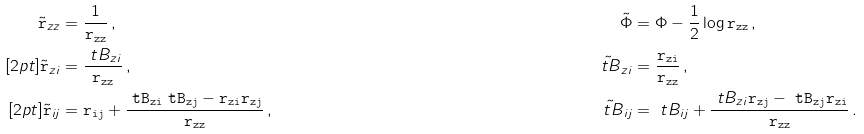Convert formula to latex. <formula><loc_0><loc_0><loc_500><loc_500>\tilde { \tt r } _ { z z } & = \frac { 1 } { \tt r _ { z z } } \, , & \tilde { \Phi } & = \Phi - \frac { 1 } { 2 } \log \tt r _ { z z } \, , \\ [ 2 p t ] \tilde { \tt r } _ { z i } & = \frac { \ t B _ { z i } } { \tt r _ { z z } } \, , & \tilde { \ t B } _ { z i } & = \frac { \tt r _ { z i } } { \tt r _ { z z } } \, , \\ [ 2 p t ] \tilde { \tt r } _ { i j } & = \tt r _ { i j } + \frac { \ t B _ { z i } \ t B _ { z j } - \tt r _ { z i } \tt r _ { z j } } { \tt r _ { z z } } \, , & \tilde { \ t B } _ { i j } & = \ t B _ { i j } + \frac { \ t B _ { z i } \tt r _ { z j } - \ t B _ { z j } \tt r _ { z i } } { \tt r _ { z z } } \, .</formula> 